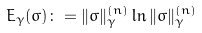<formula> <loc_0><loc_0><loc_500><loc_500>E _ { \gamma } ( \sigma ) \colon = \| \sigma \| _ { \gamma } ^ { ( n ) } \ln \| \sigma \| _ { \gamma } ^ { ( n ) }</formula> 